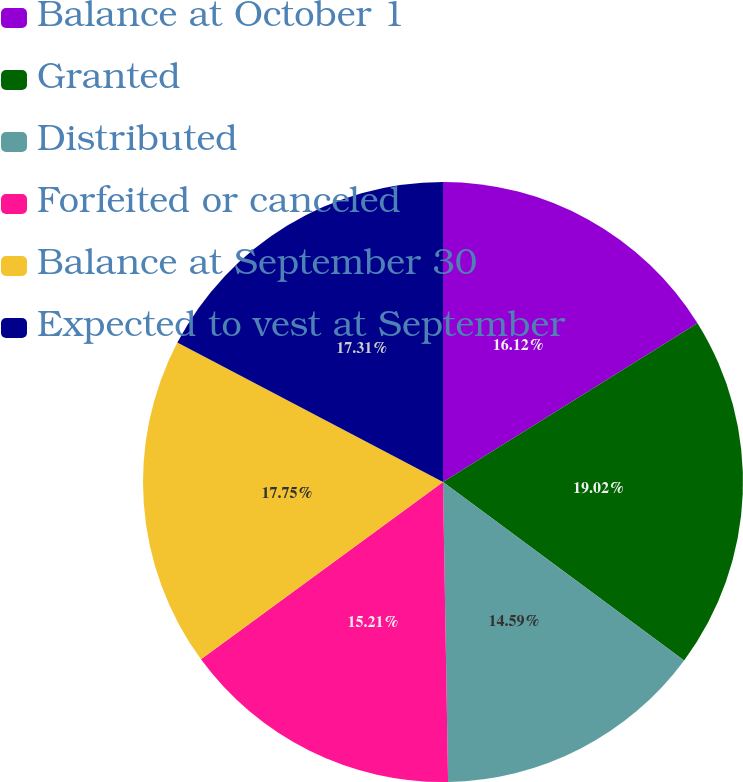Convert chart. <chart><loc_0><loc_0><loc_500><loc_500><pie_chart><fcel>Balance at October 1<fcel>Granted<fcel>Distributed<fcel>Forfeited or canceled<fcel>Balance at September 30<fcel>Expected to vest at September<nl><fcel>16.12%<fcel>19.02%<fcel>14.59%<fcel>15.21%<fcel>17.75%<fcel>17.31%<nl></chart> 